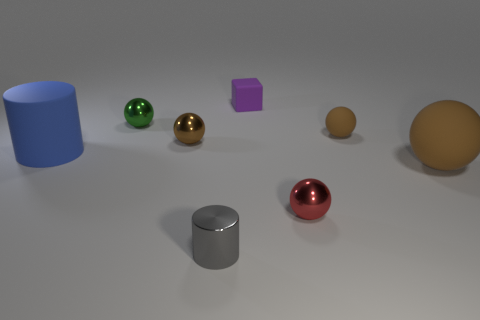Subtract all tiny red metal balls. How many balls are left? 4 Add 2 big purple matte blocks. How many objects exist? 10 Subtract all gray cylinders. How many cylinders are left? 1 Subtract all blocks. How many objects are left? 7 Subtract 2 cylinders. How many cylinders are left? 0 Subtract all blue blocks. How many brown spheres are left? 3 Subtract all small green things. Subtract all metallic spheres. How many objects are left? 4 Add 2 tiny green balls. How many tiny green balls are left? 3 Add 7 small gray metal spheres. How many small gray metal spheres exist? 7 Subtract 0 red cylinders. How many objects are left? 8 